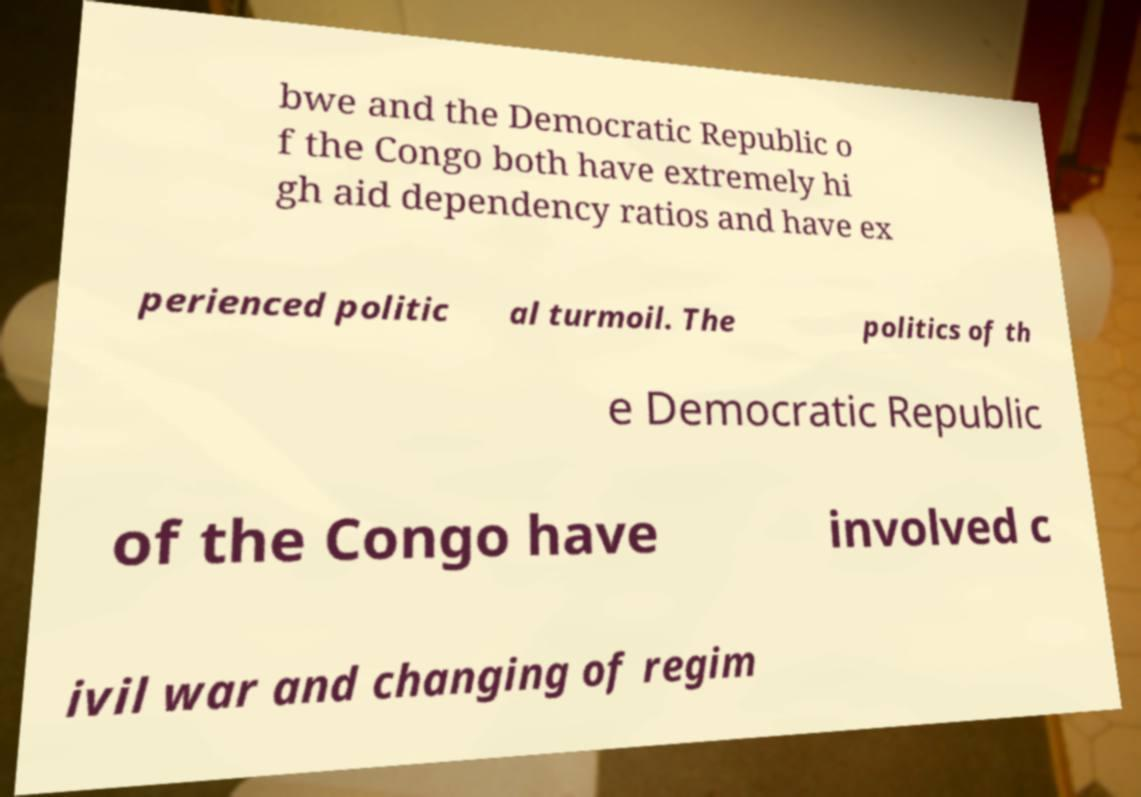Can you accurately transcribe the text from the provided image for me? bwe and the Democratic Republic o f the Congo both have extremely hi gh aid dependency ratios and have ex perienced politic al turmoil. The politics of th e Democratic Republic of the Congo have involved c ivil war and changing of regim 